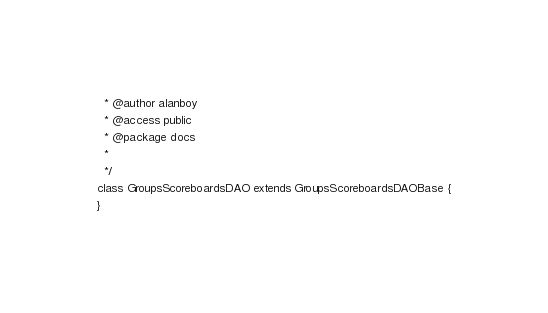Convert code to text. <code><loc_0><loc_0><loc_500><loc_500><_PHP_>  * @author alanboy
  * @access public
  * @package docs
  *
  */
class GroupsScoreboardsDAO extends GroupsScoreboardsDAOBase {
}
</code> 